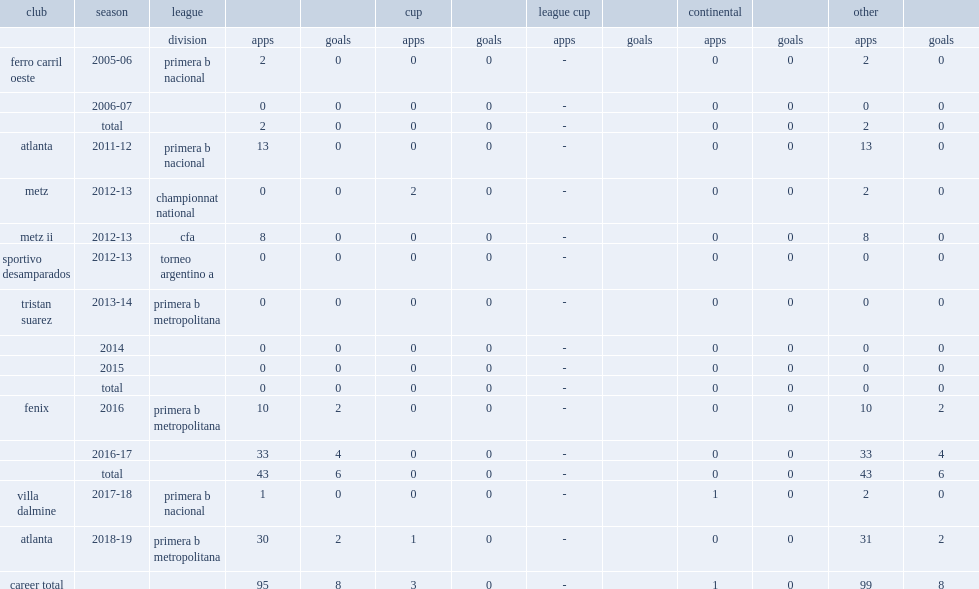Which club did cherro sign for 2016 primera b metropolitana? Fenix. 